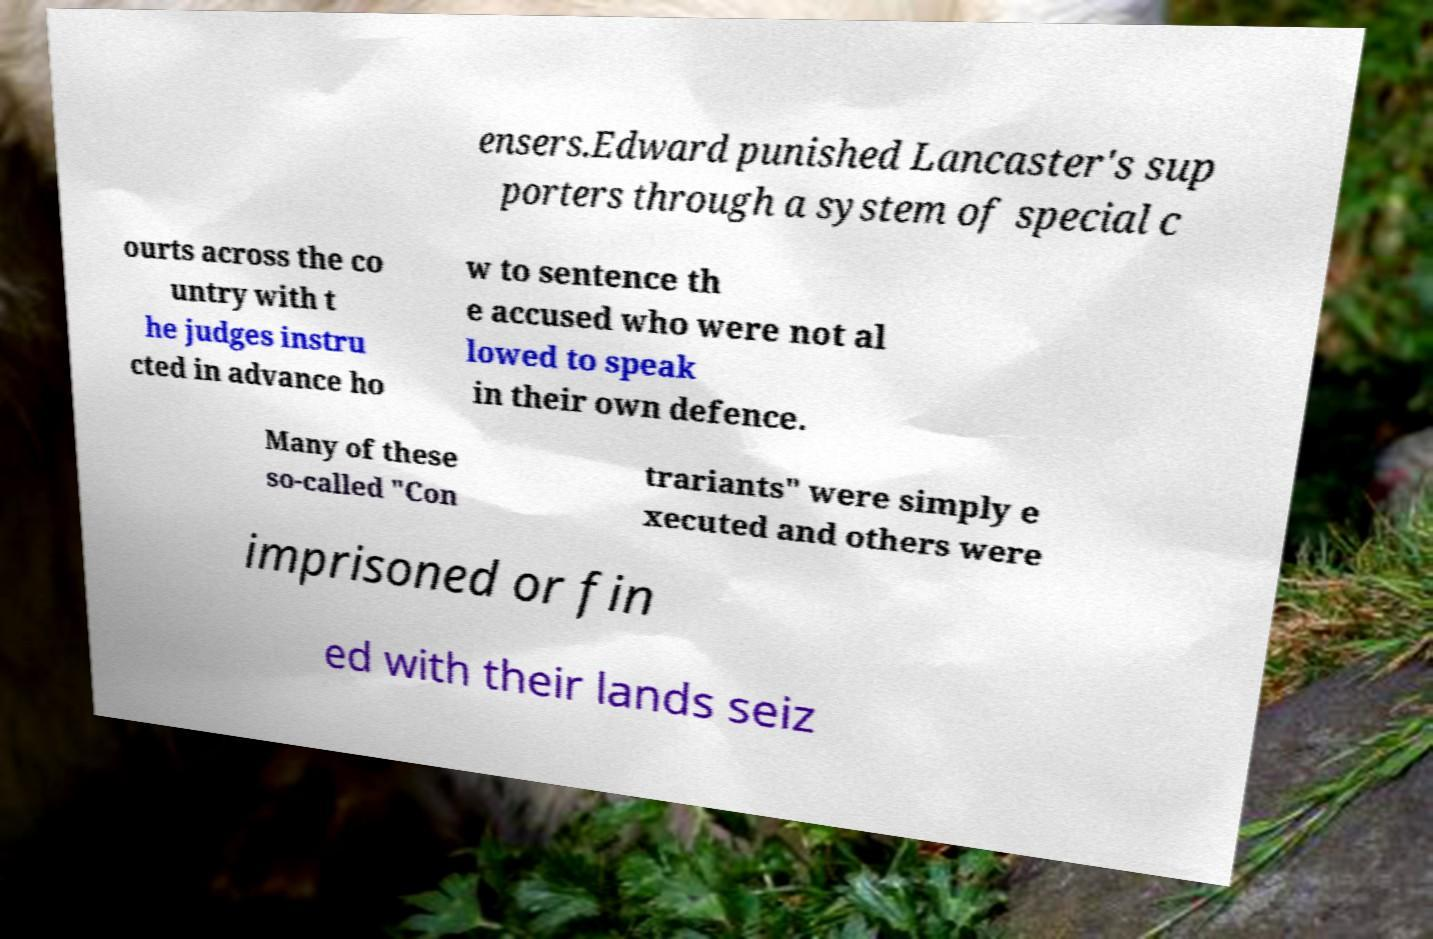There's text embedded in this image that I need extracted. Can you transcribe it verbatim? ensers.Edward punished Lancaster's sup porters through a system of special c ourts across the co untry with t he judges instru cted in advance ho w to sentence th e accused who were not al lowed to speak in their own defence. Many of these so-called "Con trariants" were simply e xecuted and others were imprisoned or fin ed with their lands seiz 